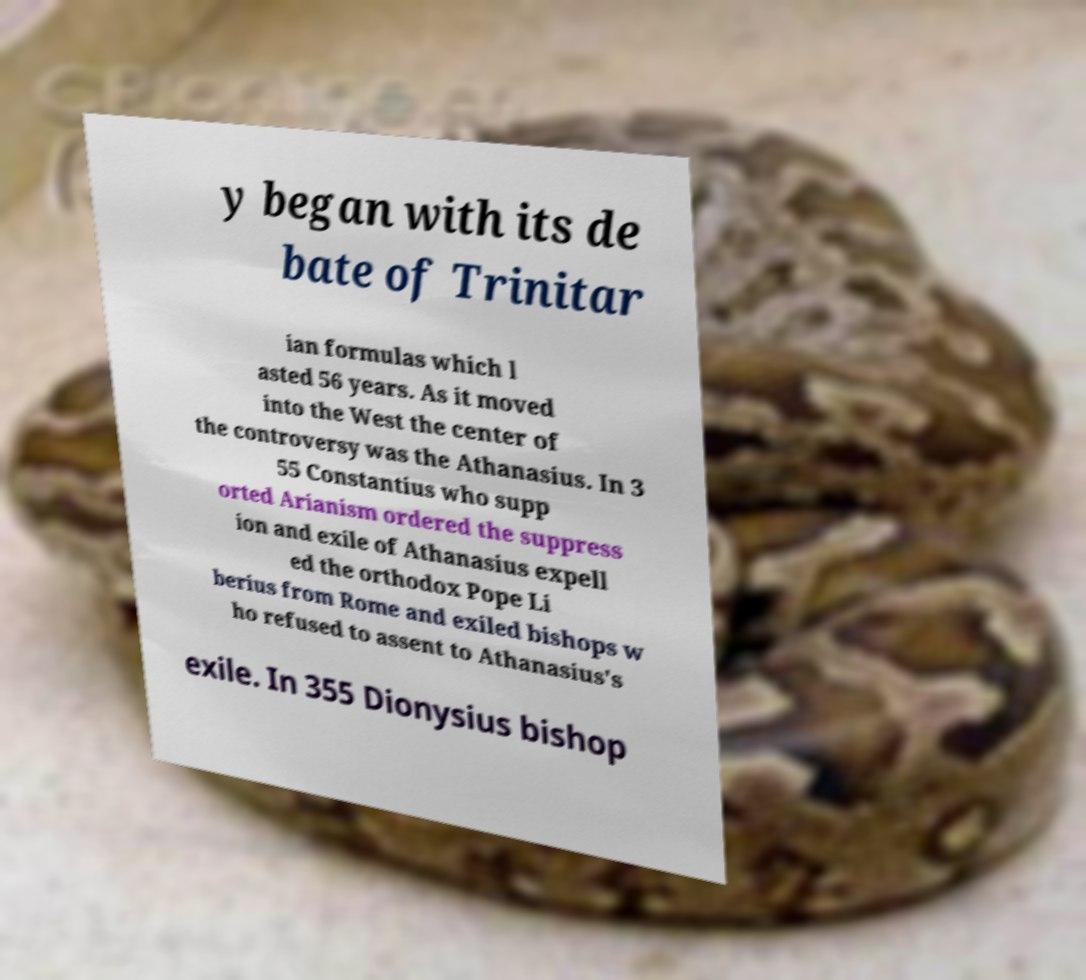Could you extract and type out the text from this image? y began with its de bate of Trinitar ian formulas which l asted 56 years. As it moved into the West the center of the controversy was the Athanasius. In 3 55 Constantius who supp orted Arianism ordered the suppress ion and exile of Athanasius expell ed the orthodox Pope Li berius from Rome and exiled bishops w ho refused to assent to Athanasius's exile. In 355 Dionysius bishop 